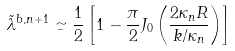<formula> <loc_0><loc_0><loc_500><loc_500>\tilde { \lambda } ^ { b , n + 1 } \simeq \frac { 1 } { 2 } \left [ 1 - \frac { \pi } { 2 } J _ { 0 } \left ( \frac { 2 \kappa _ { n } R } { k / \kappa _ { n } } \right ) \right ]</formula> 